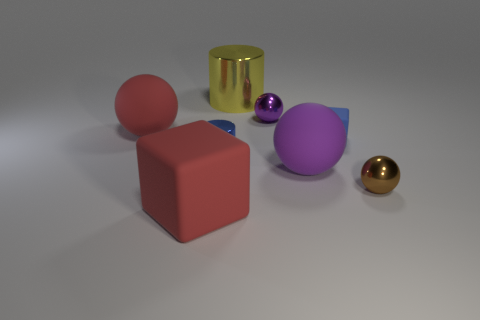How many purple balls must be subtracted to get 1 purple balls? 1 Subtract all red matte balls. How many balls are left? 3 Add 2 red spheres. How many objects exist? 10 Subtract all purple balls. How many balls are left? 2 Subtract all cyan blocks. How many purple spheres are left? 2 Subtract all cylinders. How many objects are left? 6 Subtract 2 spheres. How many spheres are left? 2 Subtract 0 green cylinders. How many objects are left? 8 Subtract all purple balls. Subtract all yellow cubes. How many balls are left? 2 Subtract all green rubber cylinders. Subtract all yellow cylinders. How many objects are left? 7 